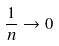Convert formula to latex. <formula><loc_0><loc_0><loc_500><loc_500>\frac { 1 } { n } \rightarrow 0</formula> 